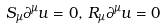<formula> <loc_0><loc_0><loc_500><loc_500>S _ { \mu } \partial ^ { \mu } u = 0 , \, R _ { \mu } \partial ^ { \mu } u = 0</formula> 